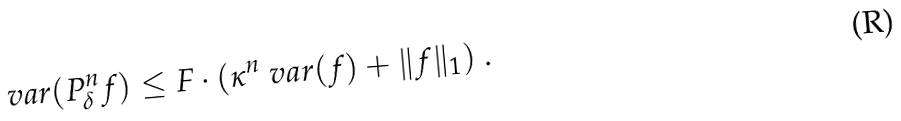<formula> <loc_0><loc_0><loc_500><loc_500>\ v a r ( P _ { \delta } ^ { n } f ) \leq F \cdot ( \kappa ^ { n } \ v a r ( f ) + \| f \| _ { 1 } ) \ .</formula> 